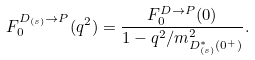Convert formula to latex. <formula><loc_0><loc_0><loc_500><loc_500>F _ { 0 } ^ { D _ { ( s ) } \rightarrow P } ( q ^ { 2 } ) = \frac { F _ { 0 } ^ { D \rightarrow P } ( 0 ) } { 1 - q ^ { 2 } / m _ { D _ { ( s ) } ^ { * } ( 0 ^ { + } ) } ^ { 2 } } .</formula> 